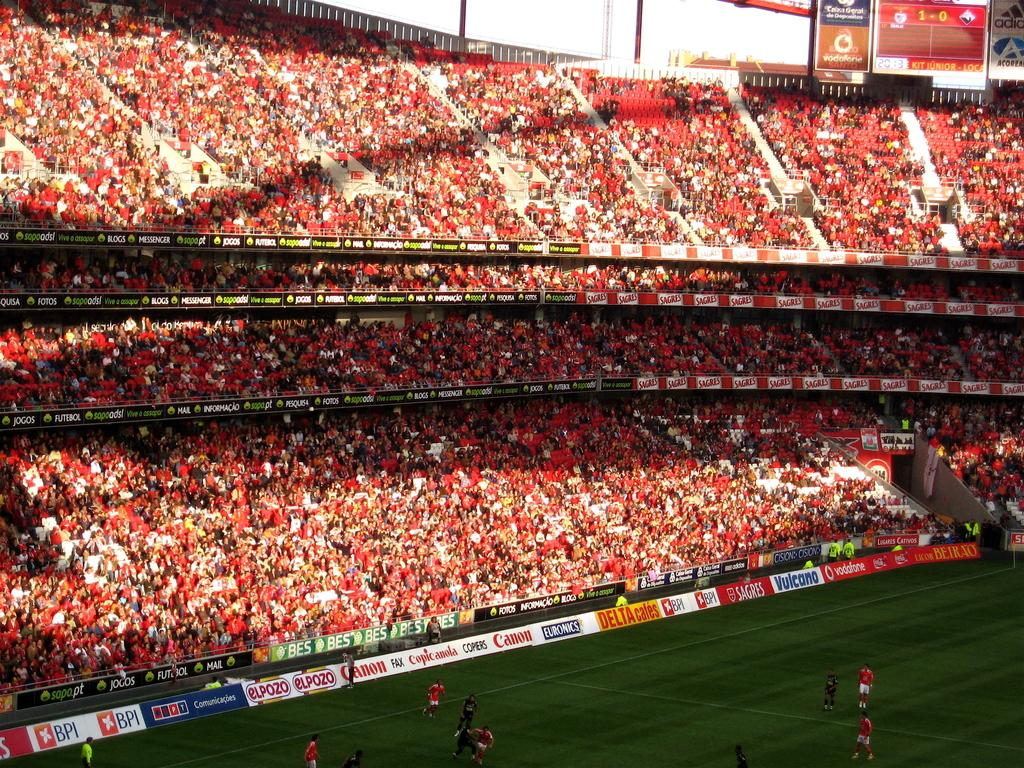<image>
Give a short and clear explanation of the subsequent image. A soccer field has advertisements for ELPOZO, Canon, Euronics, and others on its side. 